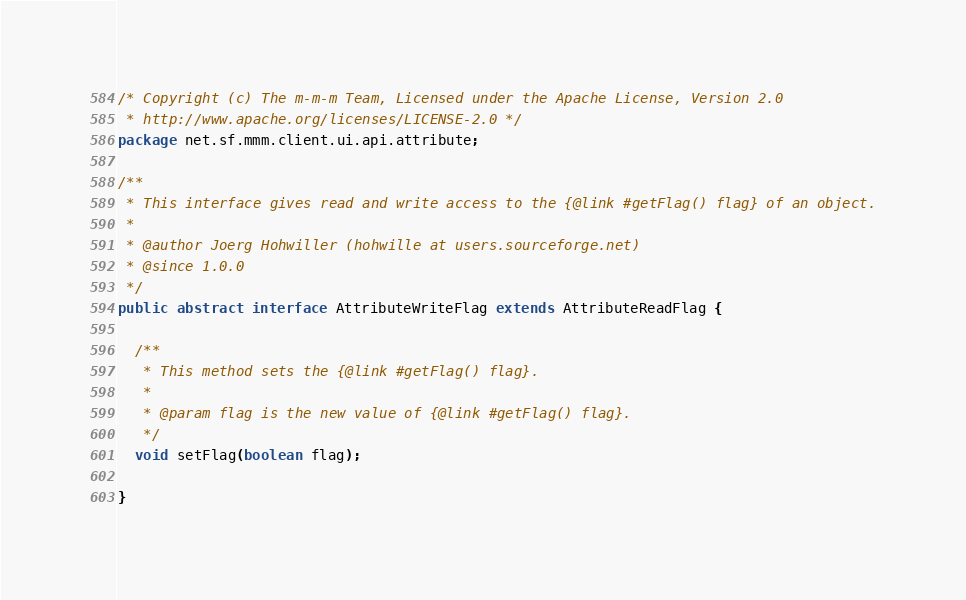<code> <loc_0><loc_0><loc_500><loc_500><_Java_>/* Copyright (c) The m-m-m Team, Licensed under the Apache License, Version 2.0
 * http://www.apache.org/licenses/LICENSE-2.0 */
package net.sf.mmm.client.ui.api.attribute;

/**
 * This interface gives read and write access to the {@link #getFlag() flag} of an object.
 * 
 * @author Joerg Hohwiller (hohwille at users.sourceforge.net)
 * @since 1.0.0
 */
public abstract interface AttributeWriteFlag extends AttributeReadFlag {

  /**
   * This method sets the {@link #getFlag() flag}.
   * 
   * @param flag is the new value of {@link #getFlag() flag}.
   */
  void setFlag(boolean flag);

}
</code> 